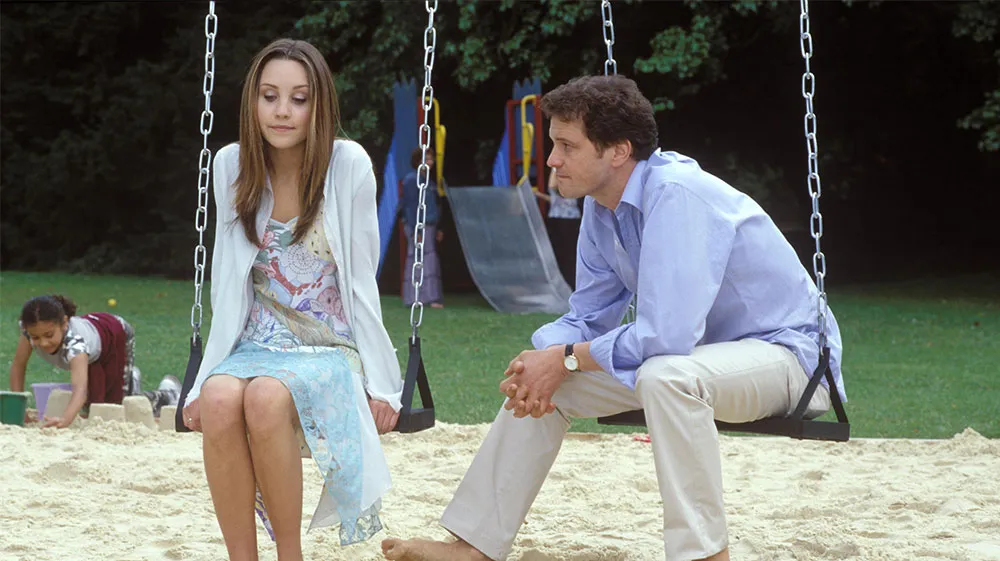Explain the visual content of the image in great detail. In this image, a relaxed scene unfolds at a local park. Two individuals, who appear deeply engrossed in conversation, are seated on separate swings facing each other. The woman, dressed in a light blue dress adorned with a delicate floral pattern, has a white cardigan over her shoulders, adding a touch of sophistication. The man, in a blue button-down shirt paired with khaki pants, sits barefoot, adding to the informal and relaxed atmosphere. The backdrop reveals a playground with children actively engaged in various activities. One child in the background is visible playing in the sandpit, contributing to the lively yet serene environment. The green foliage of the trees in the distance adds to the peaceful ambiance, making it a serene and thoughtful moment in a picturesque setting. 